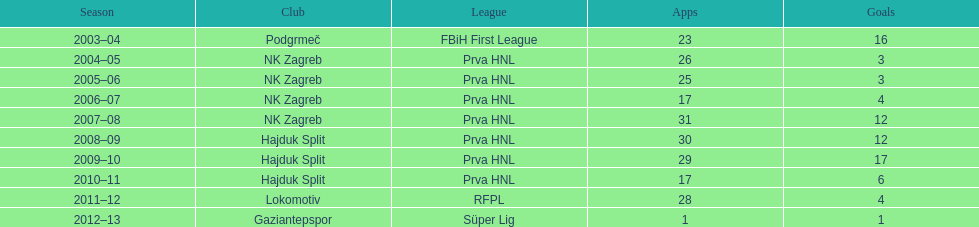Help me parse the entirety of this table. {'header': ['Season', 'Club', 'League', 'Apps', 'Goals'], 'rows': [['2003–04', 'Podgrmeč', 'FBiH First League', '23', '16'], ['2004–05', 'NK Zagreb', 'Prva HNL', '26', '3'], ['2005–06', 'NK Zagreb', 'Prva HNL', '25', '3'], ['2006–07', 'NK Zagreb', 'Prva HNL', '17', '4'], ['2007–08', 'NK Zagreb', 'Prva HNL', '31', '12'], ['2008–09', 'Hajduk Split', 'Prva HNL', '30', '12'], ['2009–10', 'Hajduk Split', 'Prva HNL', '29', '17'], ['2010–11', 'Hajduk Split', 'Prva HNL', '17', '6'], ['2011–12', 'Lokomotiv', 'RFPL', '28', '4'], ['2012–13', 'Gaziantepspor', 'Süper Lig', '1', '1']]} The team with the most goals Hajduk Split. 